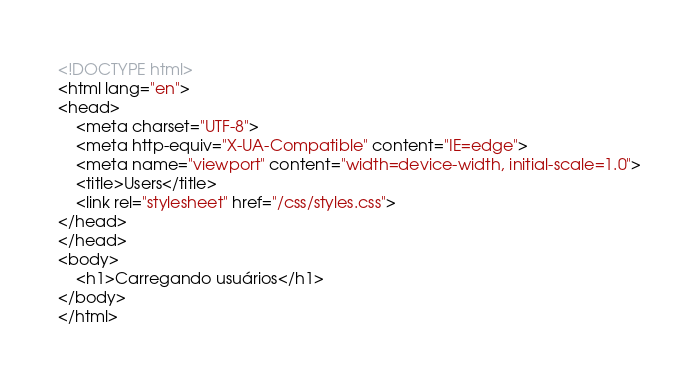Convert code to text. <code><loc_0><loc_0><loc_500><loc_500><_HTML_><!DOCTYPE html>
<html lang="en">
<head>
    <meta charset="UTF-8">
    <meta http-equiv="X-UA-Compatible" content="IE=edge">
    <meta name="viewport" content="width=device-width, initial-scale=1.0">
    <title>Users</title>
    <link rel="stylesheet" href="/css/styles.css">
</head>
</head>
<body>
    <h1>Carregando usuários</h1>
</body>
</html></code> 